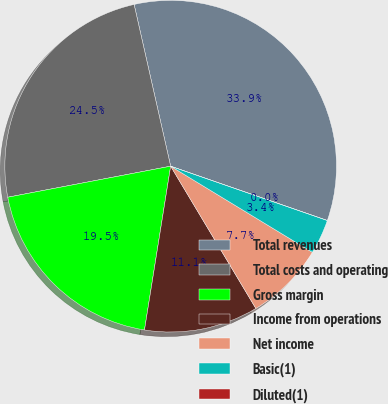Convert chart to OTSL. <chart><loc_0><loc_0><loc_500><loc_500><pie_chart><fcel>Total revenues<fcel>Total costs and operating<fcel>Gross margin<fcel>Income from operations<fcel>Net income<fcel>Basic(1)<fcel>Diluted(1)<nl><fcel>33.85%<fcel>24.46%<fcel>19.48%<fcel>11.11%<fcel>7.72%<fcel>3.38%<fcel>0.0%<nl></chart> 